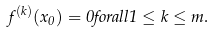<formula> <loc_0><loc_0><loc_500><loc_500>f ^ { ( k ) } ( x _ { 0 } ) = 0 f o r a l l 1 \leq k \leq m .</formula> 